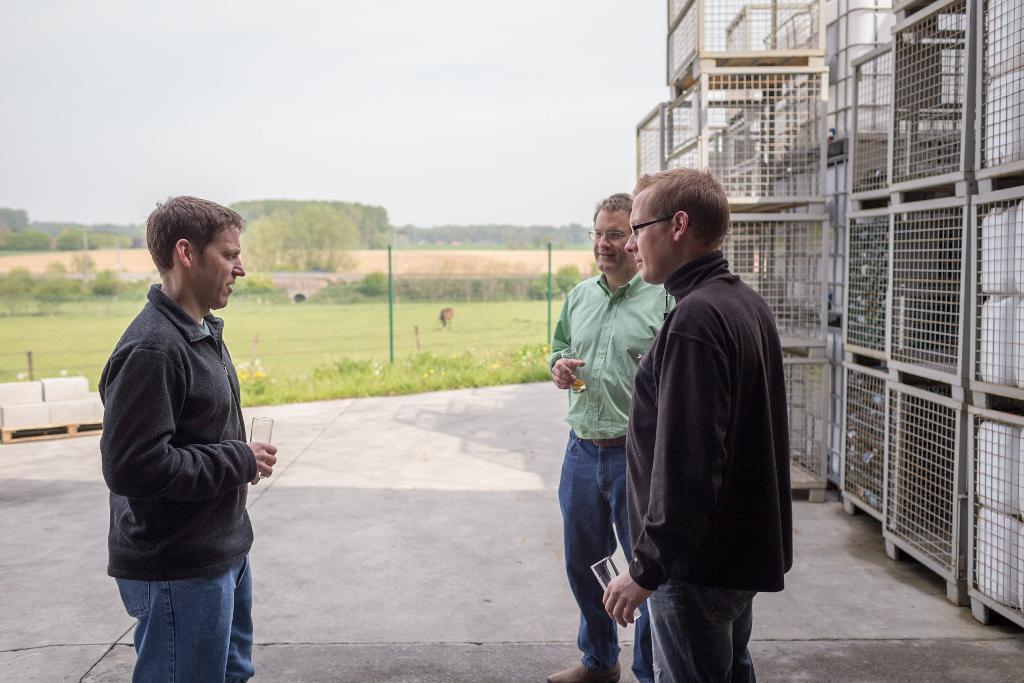How would you summarize this image in a sentence or two? On the left side, there is a person in a gray color jacket, holding a glass, standing and speaking. On the right side, there are two persons in different color dresses, wearing spectacles, holding glasses and standing, and there are cages arranged. In the background, there is a fence, there are trees, plants and grass on the ground and there are clouds in the sky. 